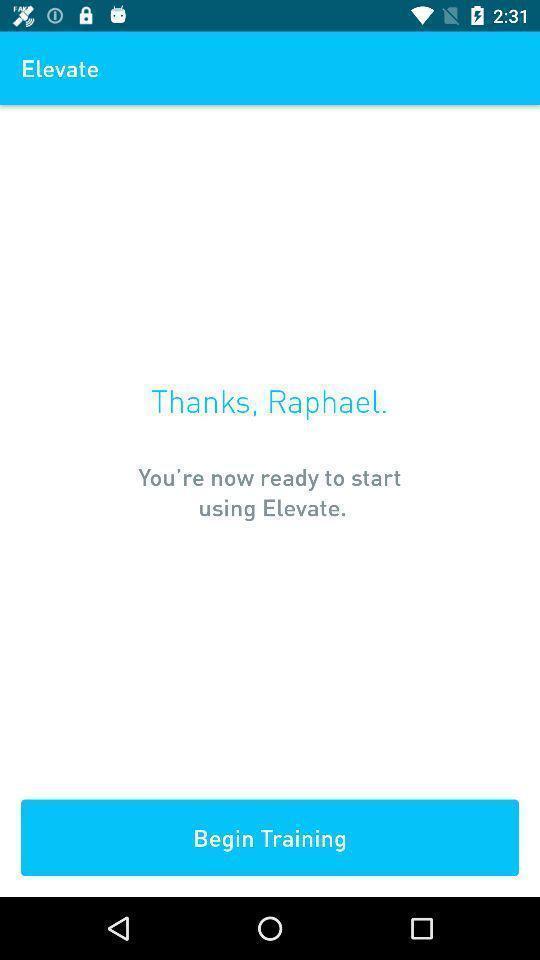Give me a narrative description of this picture. Screen shows elevate option. 